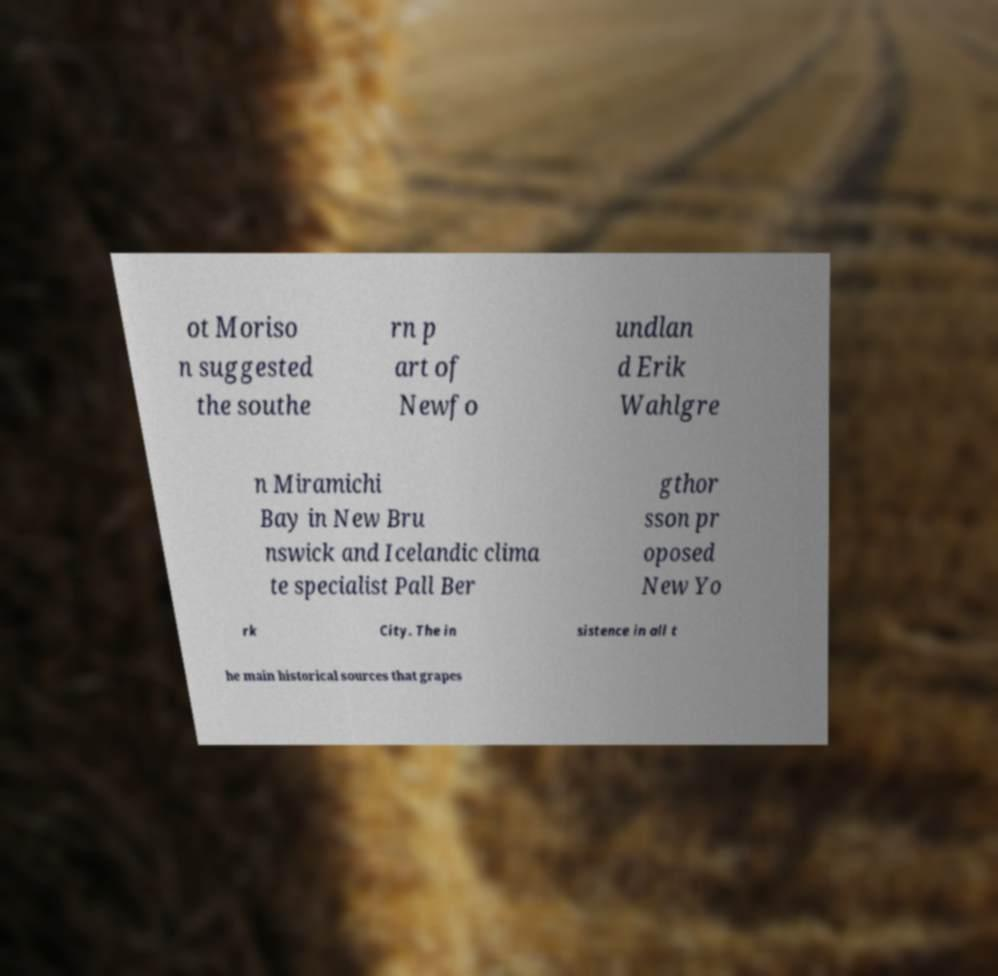Could you assist in decoding the text presented in this image and type it out clearly? ot Moriso n suggested the southe rn p art of Newfo undlan d Erik Wahlgre n Miramichi Bay in New Bru nswick and Icelandic clima te specialist Pall Ber gthor sson pr oposed New Yo rk City. The in sistence in all t he main historical sources that grapes 